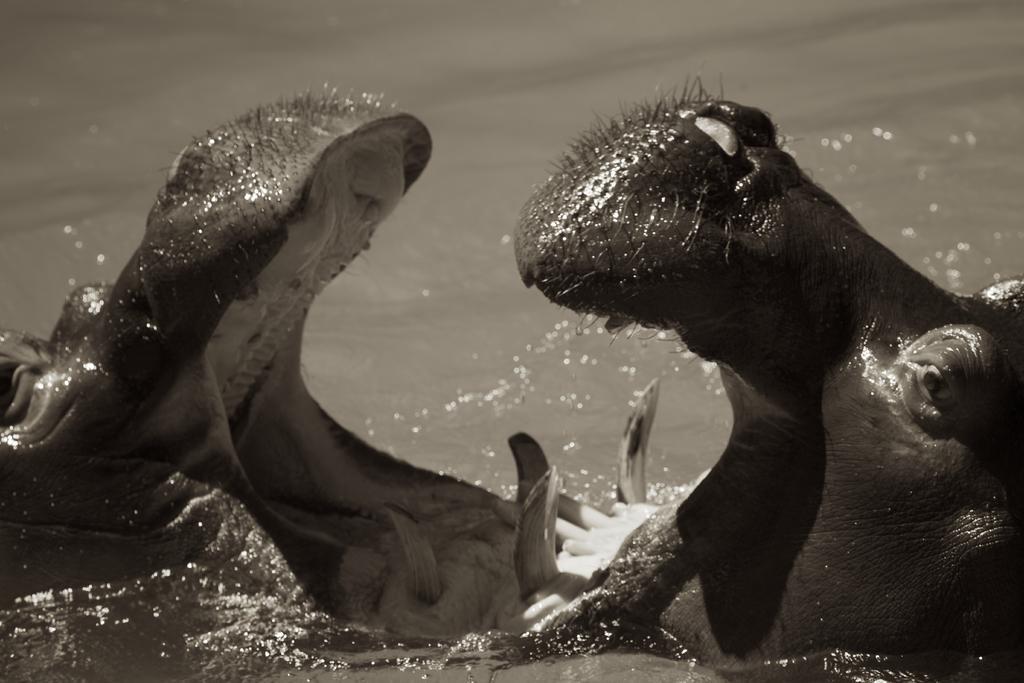Please provide a concise description of this image. This is a black and white image. In this image we can see hippopotamus in the water. 